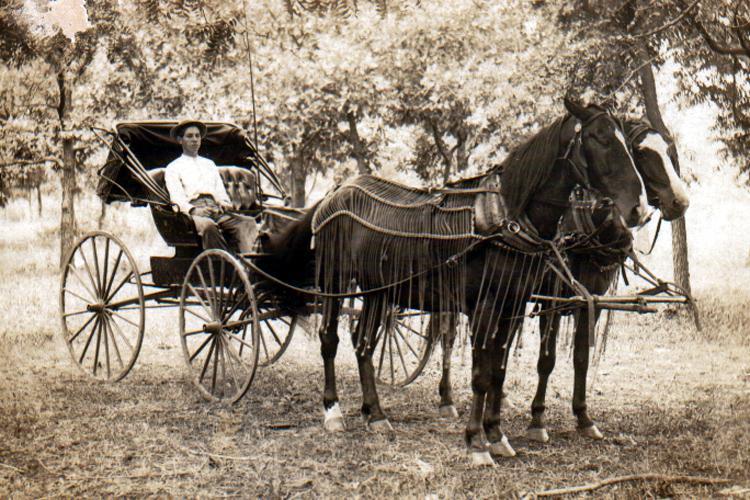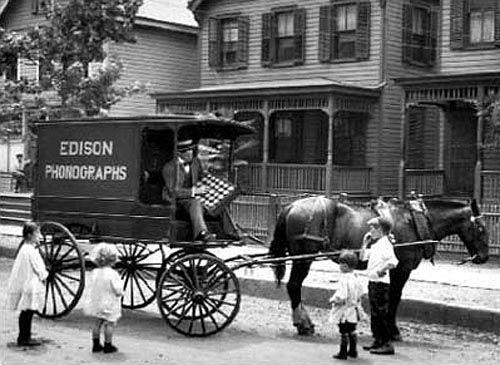The first image is the image on the left, the second image is the image on the right. For the images shown, is this caption "There is a carriage without any horses attached to it." true? Answer yes or no. No. The first image is the image on the left, the second image is the image on the right. Analyze the images presented: Is the assertion "There are multiple people being pulled in a carriage in the street by two horses in the right image." valid? Answer yes or no. No. 